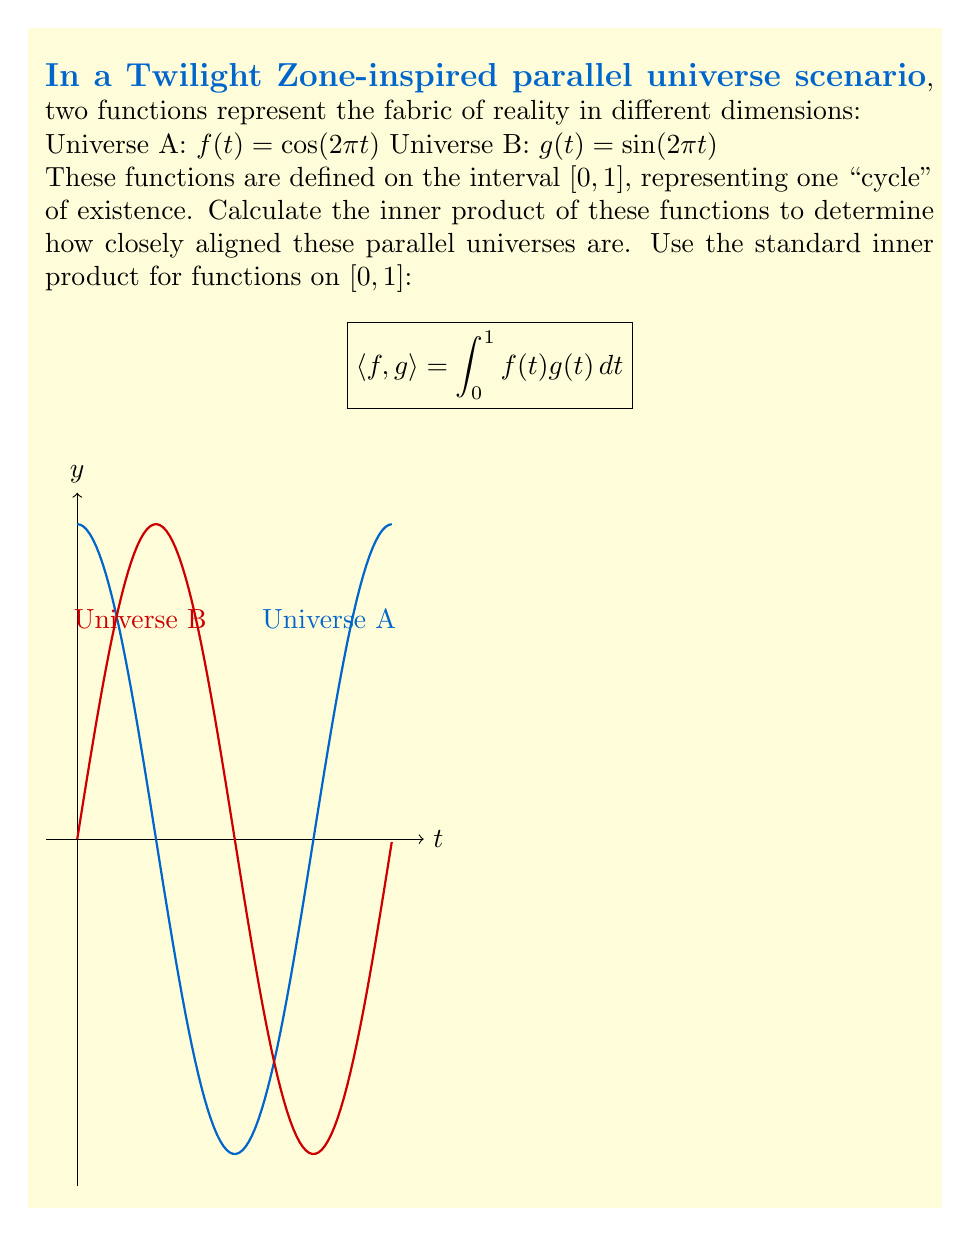Can you solve this math problem? Let's approach this step-by-step:

1) We need to calculate $\langle f, g \rangle = \int_0^1 f(t)g(t) dt$

2) Substituting our functions:
   $\langle f, g \rangle = \int_0^1 \cos(2\pi t) \sin(2\pi t) dt$

3) We can use the trigonometric identity:
   $\cos A \sin B = \frac{1}{2}[\sin(A+B) - \sin(A-B)]$

4) In our case, $A = B = 2\pi t$, so:
   $\cos(2\pi t) \sin(2\pi t) = \frac{1}{2}[\sin(4\pi t) - \sin(0)] = \frac{1}{2}\sin(4\pi t)$

5) Now our integral becomes:
   $\langle f, g \rangle = \int_0^1 \frac{1}{2}\sin(4\pi t) dt$

6) We can solve this using the antiderivative of sine:
   $\langle f, g \rangle = \frac{1}{2}[-\frac{1}{4\pi}\cos(4\pi t)]_0^1$

7) Evaluating at the bounds:
   $\langle f, g \rangle = \frac{1}{2}[-\frac{1}{4\pi}\cos(4\pi) + \frac{1}{4\pi}\cos(0)]$

8) $\cos(4\pi) = \cos(0) = 1$, so:
   $\langle f, g \rangle = \frac{1}{2}[-\frac{1}{4\pi} + \frac{1}{4\pi}] = 0$

The inner product is zero, indicating that these universes are orthogonal to each other.
Answer: $0$ 